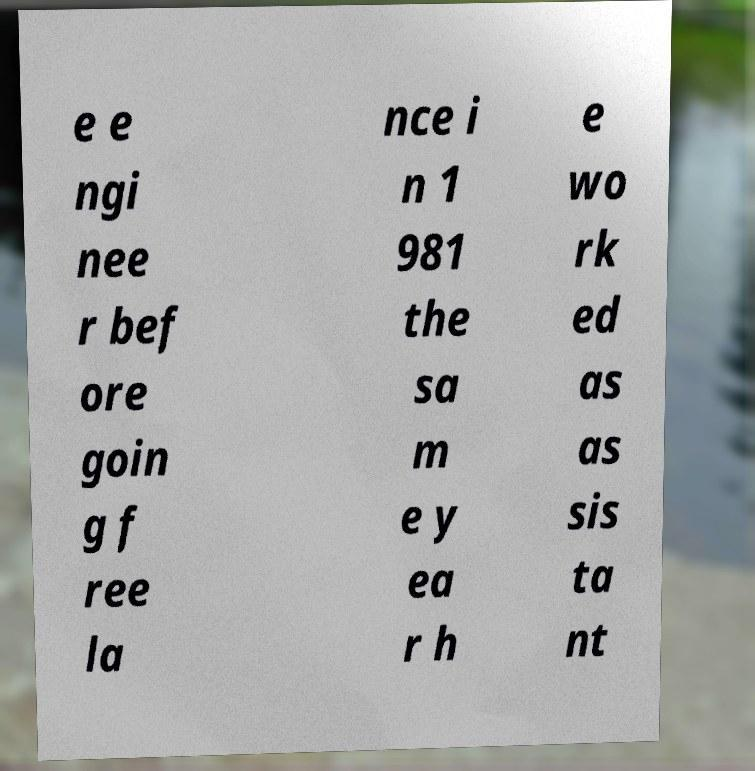Can you read and provide the text displayed in the image?This photo seems to have some interesting text. Can you extract and type it out for me? e e ngi nee r bef ore goin g f ree la nce i n 1 981 the sa m e y ea r h e wo rk ed as as sis ta nt 